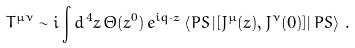Convert formula to latex. <formula><loc_0><loc_0><loc_500><loc_500>T ^ { \mu \nu } \sim i \int d ^ { \, 4 } z \, \Theta ( z ^ { 0 } ) \, e ^ { i q \cdot z } \left \langle P S \left | [ J ^ { \mu } ( z ) , J ^ { \nu } ( 0 ) ] \right | P S \right \rangle \, .</formula> 